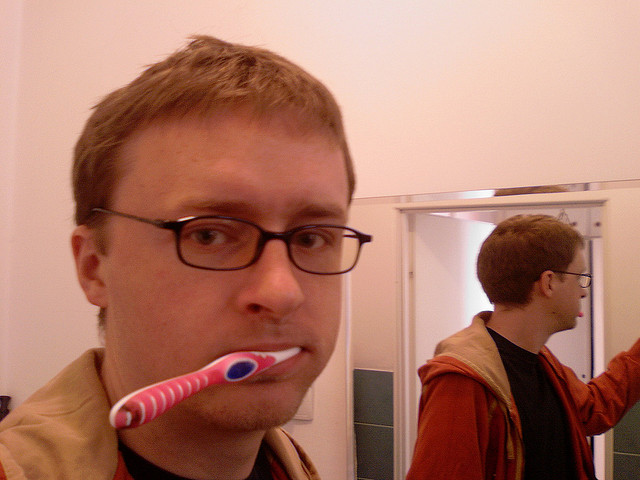<image>What hand is the boy using to brush his teeth? It is ambiguous which hand the boy is using to brush his teeth. It could be right or left hand. What hand is the boy using to brush his teeth? It is ambiguous which hand the boy is using to brush his teeth. It can be either his left or right hand. 